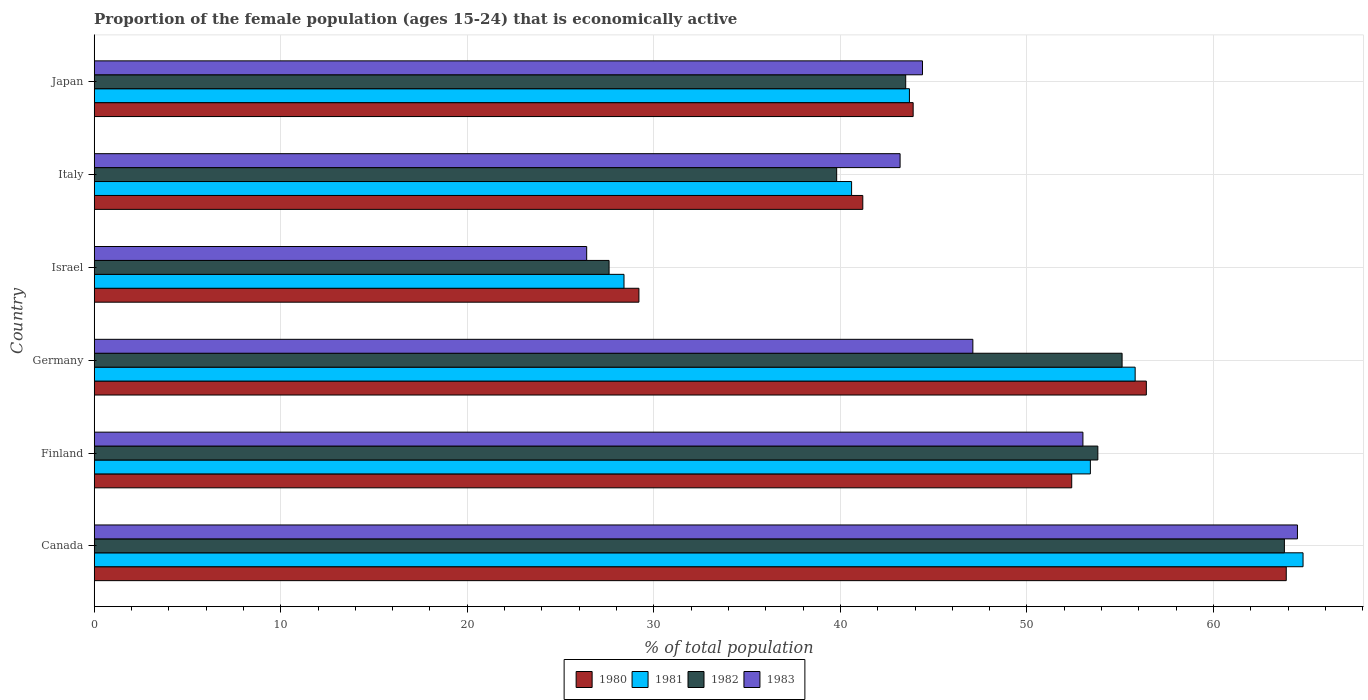Are the number of bars per tick equal to the number of legend labels?
Provide a short and direct response. Yes. Are the number of bars on each tick of the Y-axis equal?
Offer a terse response. Yes. What is the label of the 2nd group of bars from the top?
Provide a succinct answer. Italy. In how many cases, is the number of bars for a given country not equal to the number of legend labels?
Offer a terse response. 0. What is the proportion of the female population that is economically active in 1981 in Canada?
Make the answer very short. 64.8. Across all countries, what is the maximum proportion of the female population that is economically active in 1980?
Your answer should be very brief. 63.9. Across all countries, what is the minimum proportion of the female population that is economically active in 1982?
Your response must be concise. 27.6. In which country was the proportion of the female population that is economically active in 1983 maximum?
Your answer should be very brief. Canada. In which country was the proportion of the female population that is economically active in 1981 minimum?
Keep it short and to the point. Israel. What is the total proportion of the female population that is economically active in 1980 in the graph?
Your answer should be very brief. 287. What is the difference between the proportion of the female population that is economically active in 1981 in Israel and that in Italy?
Keep it short and to the point. -12.2. What is the difference between the proportion of the female population that is economically active in 1982 in Japan and the proportion of the female population that is economically active in 1981 in Canada?
Offer a terse response. -21.3. What is the average proportion of the female population that is economically active in 1982 per country?
Your answer should be very brief. 47.27. What is the difference between the proportion of the female population that is economically active in 1983 and proportion of the female population that is economically active in 1981 in Germany?
Make the answer very short. -8.7. In how many countries, is the proportion of the female population that is economically active in 1981 greater than 48 %?
Keep it short and to the point. 3. What is the ratio of the proportion of the female population that is economically active in 1982 in Canada to that in Japan?
Offer a terse response. 1.47. What is the difference between the highest and the second highest proportion of the female population that is economically active in 1981?
Your response must be concise. 9. What is the difference between the highest and the lowest proportion of the female population that is economically active in 1981?
Offer a terse response. 36.4. Is it the case that in every country, the sum of the proportion of the female population that is economically active in 1982 and proportion of the female population that is economically active in 1980 is greater than the proportion of the female population that is economically active in 1981?
Provide a short and direct response. Yes. How many bars are there?
Provide a short and direct response. 24. Are all the bars in the graph horizontal?
Offer a very short reply. Yes. How many countries are there in the graph?
Give a very brief answer. 6. Are the values on the major ticks of X-axis written in scientific E-notation?
Provide a short and direct response. No. Does the graph contain any zero values?
Provide a short and direct response. No. Does the graph contain grids?
Keep it short and to the point. Yes. Where does the legend appear in the graph?
Your answer should be compact. Bottom center. What is the title of the graph?
Your response must be concise. Proportion of the female population (ages 15-24) that is economically active. What is the label or title of the X-axis?
Your answer should be very brief. % of total population. What is the label or title of the Y-axis?
Provide a succinct answer. Country. What is the % of total population in 1980 in Canada?
Keep it short and to the point. 63.9. What is the % of total population in 1981 in Canada?
Ensure brevity in your answer.  64.8. What is the % of total population of 1982 in Canada?
Ensure brevity in your answer.  63.8. What is the % of total population in 1983 in Canada?
Provide a short and direct response. 64.5. What is the % of total population in 1980 in Finland?
Your answer should be very brief. 52.4. What is the % of total population of 1981 in Finland?
Your answer should be very brief. 53.4. What is the % of total population of 1982 in Finland?
Provide a succinct answer. 53.8. What is the % of total population in 1980 in Germany?
Your answer should be compact. 56.4. What is the % of total population in 1981 in Germany?
Offer a terse response. 55.8. What is the % of total population in 1982 in Germany?
Provide a short and direct response. 55.1. What is the % of total population in 1983 in Germany?
Make the answer very short. 47.1. What is the % of total population of 1980 in Israel?
Offer a very short reply. 29.2. What is the % of total population in 1981 in Israel?
Your answer should be compact. 28.4. What is the % of total population in 1982 in Israel?
Offer a terse response. 27.6. What is the % of total population of 1983 in Israel?
Make the answer very short. 26.4. What is the % of total population in 1980 in Italy?
Your answer should be compact. 41.2. What is the % of total population of 1981 in Italy?
Ensure brevity in your answer.  40.6. What is the % of total population in 1982 in Italy?
Make the answer very short. 39.8. What is the % of total population of 1983 in Italy?
Ensure brevity in your answer.  43.2. What is the % of total population in 1980 in Japan?
Provide a short and direct response. 43.9. What is the % of total population of 1981 in Japan?
Offer a very short reply. 43.7. What is the % of total population of 1982 in Japan?
Your response must be concise. 43.5. What is the % of total population of 1983 in Japan?
Provide a succinct answer. 44.4. Across all countries, what is the maximum % of total population in 1980?
Your response must be concise. 63.9. Across all countries, what is the maximum % of total population in 1981?
Give a very brief answer. 64.8. Across all countries, what is the maximum % of total population in 1982?
Keep it short and to the point. 63.8. Across all countries, what is the maximum % of total population of 1983?
Make the answer very short. 64.5. Across all countries, what is the minimum % of total population in 1980?
Give a very brief answer. 29.2. Across all countries, what is the minimum % of total population of 1981?
Your answer should be compact. 28.4. Across all countries, what is the minimum % of total population in 1982?
Give a very brief answer. 27.6. Across all countries, what is the minimum % of total population in 1983?
Give a very brief answer. 26.4. What is the total % of total population of 1980 in the graph?
Make the answer very short. 287. What is the total % of total population in 1981 in the graph?
Your answer should be very brief. 286.7. What is the total % of total population of 1982 in the graph?
Your response must be concise. 283.6. What is the total % of total population of 1983 in the graph?
Provide a succinct answer. 278.6. What is the difference between the % of total population of 1982 in Canada and that in Finland?
Give a very brief answer. 10. What is the difference between the % of total population of 1982 in Canada and that in Germany?
Your response must be concise. 8.7. What is the difference between the % of total population in 1983 in Canada and that in Germany?
Give a very brief answer. 17.4. What is the difference between the % of total population of 1980 in Canada and that in Israel?
Your response must be concise. 34.7. What is the difference between the % of total population of 1981 in Canada and that in Israel?
Make the answer very short. 36.4. What is the difference between the % of total population in 1982 in Canada and that in Israel?
Give a very brief answer. 36.2. What is the difference between the % of total population of 1983 in Canada and that in Israel?
Your answer should be compact. 38.1. What is the difference between the % of total population in 1980 in Canada and that in Italy?
Give a very brief answer. 22.7. What is the difference between the % of total population of 1981 in Canada and that in Italy?
Provide a succinct answer. 24.2. What is the difference between the % of total population in 1983 in Canada and that in Italy?
Your answer should be very brief. 21.3. What is the difference between the % of total population of 1981 in Canada and that in Japan?
Your response must be concise. 21.1. What is the difference between the % of total population in 1982 in Canada and that in Japan?
Give a very brief answer. 20.3. What is the difference between the % of total population in 1983 in Canada and that in Japan?
Offer a terse response. 20.1. What is the difference between the % of total population in 1980 in Finland and that in Germany?
Keep it short and to the point. -4. What is the difference between the % of total population of 1982 in Finland and that in Germany?
Your answer should be very brief. -1.3. What is the difference between the % of total population in 1983 in Finland and that in Germany?
Give a very brief answer. 5.9. What is the difference between the % of total population of 1980 in Finland and that in Israel?
Ensure brevity in your answer.  23.2. What is the difference between the % of total population in 1982 in Finland and that in Israel?
Give a very brief answer. 26.2. What is the difference between the % of total population in 1983 in Finland and that in Israel?
Your answer should be very brief. 26.6. What is the difference between the % of total population of 1980 in Finland and that in Japan?
Offer a very short reply. 8.5. What is the difference between the % of total population of 1981 in Finland and that in Japan?
Keep it short and to the point. 9.7. What is the difference between the % of total population in 1982 in Finland and that in Japan?
Offer a very short reply. 10.3. What is the difference between the % of total population of 1980 in Germany and that in Israel?
Provide a short and direct response. 27.2. What is the difference between the % of total population in 1981 in Germany and that in Israel?
Provide a short and direct response. 27.4. What is the difference between the % of total population of 1982 in Germany and that in Israel?
Your response must be concise. 27.5. What is the difference between the % of total population in 1983 in Germany and that in Israel?
Your answer should be very brief. 20.7. What is the difference between the % of total population in 1983 in Germany and that in Italy?
Offer a terse response. 3.9. What is the difference between the % of total population in 1980 in Germany and that in Japan?
Make the answer very short. 12.5. What is the difference between the % of total population in 1981 in Germany and that in Japan?
Ensure brevity in your answer.  12.1. What is the difference between the % of total population of 1982 in Germany and that in Japan?
Provide a short and direct response. 11.6. What is the difference between the % of total population of 1980 in Israel and that in Italy?
Give a very brief answer. -12. What is the difference between the % of total population in 1982 in Israel and that in Italy?
Offer a very short reply. -12.2. What is the difference between the % of total population in 1983 in Israel and that in Italy?
Ensure brevity in your answer.  -16.8. What is the difference between the % of total population in 1980 in Israel and that in Japan?
Offer a terse response. -14.7. What is the difference between the % of total population of 1981 in Israel and that in Japan?
Your answer should be compact. -15.3. What is the difference between the % of total population of 1982 in Israel and that in Japan?
Keep it short and to the point. -15.9. What is the difference between the % of total population in 1981 in Italy and that in Japan?
Offer a terse response. -3.1. What is the difference between the % of total population in 1982 in Italy and that in Japan?
Ensure brevity in your answer.  -3.7. What is the difference between the % of total population in 1983 in Italy and that in Japan?
Your answer should be very brief. -1.2. What is the difference between the % of total population of 1980 in Canada and the % of total population of 1983 in Finland?
Provide a short and direct response. 10.9. What is the difference between the % of total population in 1981 in Canada and the % of total population in 1982 in Finland?
Your answer should be very brief. 11. What is the difference between the % of total population in 1981 in Canada and the % of total population in 1983 in Finland?
Give a very brief answer. 11.8. What is the difference between the % of total population of 1980 in Canada and the % of total population of 1983 in Germany?
Offer a terse response. 16.8. What is the difference between the % of total population in 1982 in Canada and the % of total population in 1983 in Germany?
Offer a terse response. 16.7. What is the difference between the % of total population of 1980 in Canada and the % of total population of 1981 in Israel?
Your answer should be compact. 35.5. What is the difference between the % of total population of 1980 in Canada and the % of total population of 1982 in Israel?
Your answer should be compact. 36.3. What is the difference between the % of total population of 1980 in Canada and the % of total population of 1983 in Israel?
Your answer should be very brief. 37.5. What is the difference between the % of total population of 1981 in Canada and the % of total population of 1982 in Israel?
Offer a terse response. 37.2. What is the difference between the % of total population of 1981 in Canada and the % of total population of 1983 in Israel?
Ensure brevity in your answer.  38.4. What is the difference between the % of total population in 1982 in Canada and the % of total population in 1983 in Israel?
Keep it short and to the point. 37.4. What is the difference between the % of total population in 1980 in Canada and the % of total population in 1981 in Italy?
Offer a terse response. 23.3. What is the difference between the % of total population in 1980 in Canada and the % of total population in 1982 in Italy?
Make the answer very short. 24.1. What is the difference between the % of total population in 1980 in Canada and the % of total population in 1983 in Italy?
Ensure brevity in your answer.  20.7. What is the difference between the % of total population of 1981 in Canada and the % of total population of 1983 in Italy?
Provide a short and direct response. 21.6. What is the difference between the % of total population of 1982 in Canada and the % of total population of 1983 in Italy?
Provide a short and direct response. 20.6. What is the difference between the % of total population in 1980 in Canada and the % of total population in 1981 in Japan?
Offer a terse response. 20.2. What is the difference between the % of total population of 1980 in Canada and the % of total population of 1982 in Japan?
Provide a short and direct response. 20.4. What is the difference between the % of total population of 1980 in Canada and the % of total population of 1983 in Japan?
Offer a very short reply. 19.5. What is the difference between the % of total population in 1981 in Canada and the % of total population in 1982 in Japan?
Ensure brevity in your answer.  21.3. What is the difference between the % of total population in 1981 in Canada and the % of total population in 1983 in Japan?
Keep it short and to the point. 20.4. What is the difference between the % of total population in 1980 in Finland and the % of total population in 1981 in Germany?
Your answer should be compact. -3.4. What is the difference between the % of total population in 1981 in Finland and the % of total population in 1983 in Germany?
Give a very brief answer. 6.3. What is the difference between the % of total population of 1982 in Finland and the % of total population of 1983 in Germany?
Provide a succinct answer. 6.7. What is the difference between the % of total population in 1980 in Finland and the % of total population in 1981 in Israel?
Ensure brevity in your answer.  24. What is the difference between the % of total population in 1980 in Finland and the % of total population in 1982 in Israel?
Your answer should be compact. 24.8. What is the difference between the % of total population of 1980 in Finland and the % of total population of 1983 in Israel?
Offer a terse response. 26. What is the difference between the % of total population of 1981 in Finland and the % of total population of 1982 in Israel?
Your response must be concise. 25.8. What is the difference between the % of total population in 1982 in Finland and the % of total population in 1983 in Israel?
Provide a short and direct response. 27.4. What is the difference between the % of total population in 1980 in Finland and the % of total population in 1981 in Italy?
Offer a terse response. 11.8. What is the difference between the % of total population of 1980 in Finland and the % of total population of 1982 in Italy?
Give a very brief answer. 12.6. What is the difference between the % of total population in 1980 in Finland and the % of total population in 1983 in Italy?
Your response must be concise. 9.2. What is the difference between the % of total population of 1982 in Finland and the % of total population of 1983 in Italy?
Give a very brief answer. 10.6. What is the difference between the % of total population of 1982 in Finland and the % of total population of 1983 in Japan?
Provide a succinct answer. 9.4. What is the difference between the % of total population in 1980 in Germany and the % of total population in 1982 in Israel?
Provide a succinct answer. 28.8. What is the difference between the % of total population in 1980 in Germany and the % of total population in 1983 in Israel?
Make the answer very short. 30. What is the difference between the % of total population of 1981 in Germany and the % of total population of 1982 in Israel?
Offer a terse response. 28.2. What is the difference between the % of total population of 1981 in Germany and the % of total population of 1983 in Israel?
Provide a short and direct response. 29.4. What is the difference between the % of total population of 1982 in Germany and the % of total population of 1983 in Israel?
Make the answer very short. 28.7. What is the difference between the % of total population of 1980 in Germany and the % of total population of 1981 in Italy?
Ensure brevity in your answer.  15.8. What is the difference between the % of total population of 1980 in Germany and the % of total population of 1983 in Japan?
Your answer should be very brief. 12. What is the difference between the % of total population in 1981 in Germany and the % of total population in 1982 in Japan?
Keep it short and to the point. 12.3. What is the difference between the % of total population in 1980 in Israel and the % of total population in 1981 in Italy?
Keep it short and to the point. -11.4. What is the difference between the % of total population in 1980 in Israel and the % of total population in 1982 in Italy?
Offer a terse response. -10.6. What is the difference between the % of total population in 1981 in Israel and the % of total population in 1982 in Italy?
Ensure brevity in your answer.  -11.4. What is the difference between the % of total population in 1981 in Israel and the % of total population in 1983 in Italy?
Provide a short and direct response. -14.8. What is the difference between the % of total population in 1982 in Israel and the % of total population in 1983 in Italy?
Ensure brevity in your answer.  -15.6. What is the difference between the % of total population of 1980 in Israel and the % of total population of 1981 in Japan?
Your answer should be compact. -14.5. What is the difference between the % of total population of 1980 in Israel and the % of total population of 1982 in Japan?
Offer a very short reply. -14.3. What is the difference between the % of total population of 1980 in Israel and the % of total population of 1983 in Japan?
Give a very brief answer. -15.2. What is the difference between the % of total population of 1981 in Israel and the % of total population of 1982 in Japan?
Make the answer very short. -15.1. What is the difference between the % of total population in 1982 in Israel and the % of total population in 1983 in Japan?
Ensure brevity in your answer.  -16.8. What is the difference between the % of total population of 1980 in Italy and the % of total population of 1981 in Japan?
Keep it short and to the point. -2.5. What is the difference between the % of total population of 1980 in Italy and the % of total population of 1982 in Japan?
Provide a succinct answer. -2.3. What is the difference between the % of total population of 1980 in Italy and the % of total population of 1983 in Japan?
Provide a succinct answer. -3.2. What is the difference between the % of total population in 1981 in Italy and the % of total population in 1983 in Japan?
Make the answer very short. -3.8. What is the difference between the % of total population in 1982 in Italy and the % of total population in 1983 in Japan?
Provide a succinct answer. -4.6. What is the average % of total population of 1980 per country?
Provide a short and direct response. 47.83. What is the average % of total population in 1981 per country?
Your answer should be compact. 47.78. What is the average % of total population in 1982 per country?
Offer a terse response. 47.27. What is the average % of total population of 1983 per country?
Keep it short and to the point. 46.43. What is the difference between the % of total population in 1980 and % of total population in 1981 in Canada?
Your response must be concise. -0.9. What is the difference between the % of total population in 1982 and % of total population in 1983 in Canada?
Keep it short and to the point. -0.7. What is the difference between the % of total population in 1980 and % of total population in 1981 in Finland?
Keep it short and to the point. -1. What is the difference between the % of total population in 1981 and % of total population in 1982 in Finland?
Your answer should be compact. -0.4. What is the difference between the % of total population of 1982 and % of total population of 1983 in Finland?
Make the answer very short. 0.8. What is the difference between the % of total population of 1980 and % of total population of 1981 in Germany?
Your answer should be compact. 0.6. What is the difference between the % of total population in 1980 and % of total population in 1983 in Germany?
Provide a succinct answer. 9.3. What is the difference between the % of total population of 1981 and % of total population of 1982 in Germany?
Your answer should be compact. 0.7. What is the difference between the % of total population in 1982 and % of total population in 1983 in Germany?
Your answer should be compact. 8. What is the difference between the % of total population of 1980 and % of total population of 1981 in Israel?
Your answer should be very brief. 0.8. What is the difference between the % of total population in 1980 and % of total population in 1982 in Israel?
Give a very brief answer. 1.6. What is the difference between the % of total population in 1981 and % of total population in 1982 in Israel?
Your answer should be compact. 0.8. What is the difference between the % of total population of 1982 and % of total population of 1983 in Israel?
Ensure brevity in your answer.  1.2. What is the difference between the % of total population in 1980 and % of total population in 1983 in Italy?
Your answer should be compact. -2. What is the difference between the % of total population of 1982 and % of total population of 1983 in Italy?
Your answer should be very brief. -3.4. What is the difference between the % of total population in 1980 and % of total population in 1982 in Japan?
Your response must be concise. 0.4. What is the difference between the % of total population in 1980 and % of total population in 1983 in Japan?
Make the answer very short. -0.5. What is the difference between the % of total population of 1981 and % of total population of 1982 in Japan?
Make the answer very short. 0.2. What is the difference between the % of total population of 1981 and % of total population of 1983 in Japan?
Ensure brevity in your answer.  -0.7. What is the difference between the % of total population in 1982 and % of total population in 1983 in Japan?
Ensure brevity in your answer.  -0.9. What is the ratio of the % of total population of 1980 in Canada to that in Finland?
Offer a very short reply. 1.22. What is the ratio of the % of total population in 1981 in Canada to that in Finland?
Provide a short and direct response. 1.21. What is the ratio of the % of total population of 1982 in Canada to that in Finland?
Keep it short and to the point. 1.19. What is the ratio of the % of total population of 1983 in Canada to that in Finland?
Provide a short and direct response. 1.22. What is the ratio of the % of total population in 1980 in Canada to that in Germany?
Make the answer very short. 1.13. What is the ratio of the % of total population of 1981 in Canada to that in Germany?
Give a very brief answer. 1.16. What is the ratio of the % of total population in 1982 in Canada to that in Germany?
Offer a very short reply. 1.16. What is the ratio of the % of total population of 1983 in Canada to that in Germany?
Ensure brevity in your answer.  1.37. What is the ratio of the % of total population in 1980 in Canada to that in Israel?
Ensure brevity in your answer.  2.19. What is the ratio of the % of total population in 1981 in Canada to that in Israel?
Your response must be concise. 2.28. What is the ratio of the % of total population of 1982 in Canada to that in Israel?
Provide a succinct answer. 2.31. What is the ratio of the % of total population of 1983 in Canada to that in Israel?
Your answer should be compact. 2.44. What is the ratio of the % of total population of 1980 in Canada to that in Italy?
Your answer should be very brief. 1.55. What is the ratio of the % of total population of 1981 in Canada to that in Italy?
Your answer should be compact. 1.6. What is the ratio of the % of total population in 1982 in Canada to that in Italy?
Make the answer very short. 1.6. What is the ratio of the % of total population of 1983 in Canada to that in Italy?
Your answer should be compact. 1.49. What is the ratio of the % of total population of 1980 in Canada to that in Japan?
Ensure brevity in your answer.  1.46. What is the ratio of the % of total population in 1981 in Canada to that in Japan?
Your answer should be very brief. 1.48. What is the ratio of the % of total population of 1982 in Canada to that in Japan?
Your answer should be compact. 1.47. What is the ratio of the % of total population in 1983 in Canada to that in Japan?
Your response must be concise. 1.45. What is the ratio of the % of total population of 1980 in Finland to that in Germany?
Your answer should be very brief. 0.93. What is the ratio of the % of total population of 1981 in Finland to that in Germany?
Your answer should be very brief. 0.96. What is the ratio of the % of total population of 1982 in Finland to that in Germany?
Keep it short and to the point. 0.98. What is the ratio of the % of total population in 1983 in Finland to that in Germany?
Offer a very short reply. 1.13. What is the ratio of the % of total population in 1980 in Finland to that in Israel?
Provide a short and direct response. 1.79. What is the ratio of the % of total population in 1981 in Finland to that in Israel?
Provide a short and direct response. 1.88. What is the ratio of the % of total population in 1982 in Finland to that in Israel?
Provide a succinct answer. 1.95. What is the ratio of the % of total population in 1983 in Finland to that in Israel?
Your answer should be compact. 2.01. What is the ratio of the % of total population in 1980 in Finland to that in Italy?
Your answer should be very brief. 1.27. What is the ratio of the % of total population in 1981 in Finland to that in Italy?
Give a very brief answer. 1.32. What is the ratio of the % of total population of 1982 in Finland to that in Italy?
Your answer should be very brief. 1.35. What is the ratio of the % of total population in 1983 in Finland to that in Italy?
Ensure brevity in your answer.  1.23. What is the ratio of the % of total population in 1980 in Finland to that in Japan?
Your answer should be very brief. 1.19. What is the ratio of the % of total population in 1981 in Finland to that in Japan?
Provide a succinct answer. 1.22. What is the ratio of the % of total population of 1982 in Finland to that in Japan?
Offer a very short reply. 1.24. What is the ratio of the % of total population in 1983 in Finland to that in Japan?
Your response must be concise. 1.19. What is the ratio of the % of total population of 1980 in Germany to that in Israel?
Your answer should be compact. 1.93. What is the ratio of the % of total population of 1981 in Germany to that in Israel?
Give a very brief answer. 1.96. What is the ratio of the % of total population in 1982 in Germany to that in Israel?
Provide a short and direct response. 2. What is the ratio of the % of total population in 1983 in Germany to that in Israel?
Offer a very short reply. 1.78. What is the ratio of the % of total population of 1980 in Germany to that in Italy?
Keep it short and to the point. 1.37. What is the ratio of the % of total population of 1981 in Germany to that in Italy?
Keep it short and to the point. 1.37. What is the ratio of the % of total population in 1982 in Germany to that in Italy?
Make the answer very short. 1.38. What is the ratio of the % of total population in 1983 in Germany to that in Italy?
Give a very brief answer. 1.09. What is the ratio of the % of total population in 1980 in Germany to that in Japan?
Provide a short and direct response. 1.28. What is the ratio of the % of total population in 1981 in Germany to that in Japan?
Provide a succinct answer. 1.28. What is the ratio of the % of total population of 1982 in Germany to that in Japan?
Your response must be concise. 1.27. What is the ratio of the % of total population in 1983 in Germany to that in Japan?
Ensure brevity in your answer.  1.06. What is the ratio of the % of total population of 1980 in Israel to that in Italy?
Provide a short and direct response. 0.71. What is the ratio of the % of total population in 1981 in Israel to that in Italy?
Make the answer very short. 0.7. What is the ratio of the % of total population in 1982 in Israel to that in Italy?
Your response must be concise. 0.69. What is the ratio of the % of total population of 1983 in Israel to that in Italy?
Ensure brevity in your answer.  0.61. What is the ratio of the % of total population in 1980 in Israel to that in Japan?
Keep it short and to the point. 0.67. What is the ratio of the % of total population of 1981 in Israel to that in Japan?
Your response must be concise. 0.65. What is the ratio of the % of total population in 1982 in Israel to that in Japan?
Your response must be concise. 0.63. What is the ratio of the % of total population of 1983 in Israel to that in Japan?
Provide a succinct answer. 0.59. What is the ratio of the % of total population in 1980 in Italy to that in Japan?
Your answer should be compact. 0.94. What is the ratio of the % of total population in 1981 in Italy to that in Japan?
Provide a short and direct response. 0.93. What is the ratio of the % of total population of 1982 in Italy to that in Japan?
Give a very brief answer. 0.91. What is the ratio of the % of total population in 1983 in Italy to that in Japan?
Your answer should be very brief. 0.97. What is the difference between the highest and the second highest % of total population of 1981?
Offer a very short reply. 9. What is the difference between the highest and the second highest % of total population in 1983?
Make the answer very short. 11.5. What is the difference between the highest and the lowest % of total population in 1980?
Make the answer very short. 34.7. What is the difference between the highest and the lowest % of total population in 1981?
Offer a very short reply. 36.4. What is the difference between the highest and the lowest % of total population in 1982?
Provide a succinct answer. 36.2. What is the difference between the highest and the lowest % of total population in 1983?
Provide a short and direct response. 38.1. 